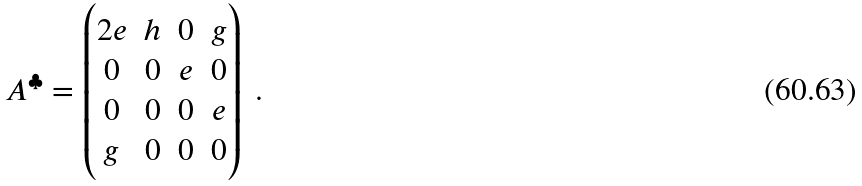Convert formula to latex. <formula><loc_0><loc_0><loc_500><loc_500>A ^ { \clubsuit } = \begin{pmatrix} 2 e & h & 0 & g \\ 0 & 0 & e & 0 \\ 0 & 0 & 0 & e \\ g & 0 & 0 & 0 \end{pmatrix} \ .</formula> 